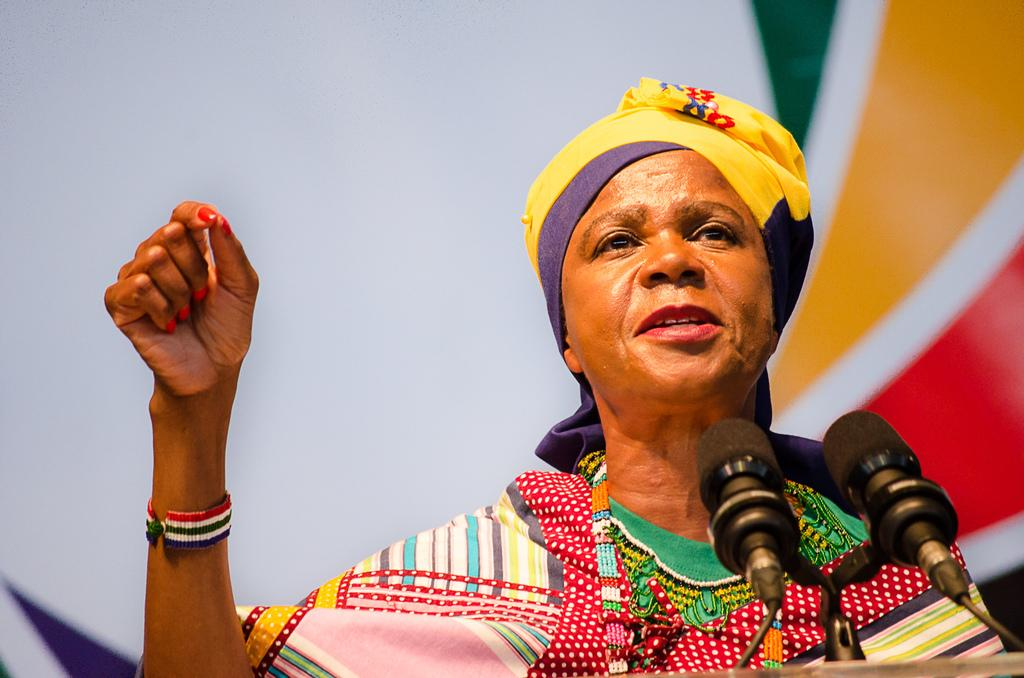Who is present in the image? There is a person in the image. What is the person doing in the image? The person is speaking. What objects are in front of the person? There are two microphones in front of the person. What type of animal is sitting on the person's leg in the image? There is no animal present in the image, and the person's leg is not visible. 